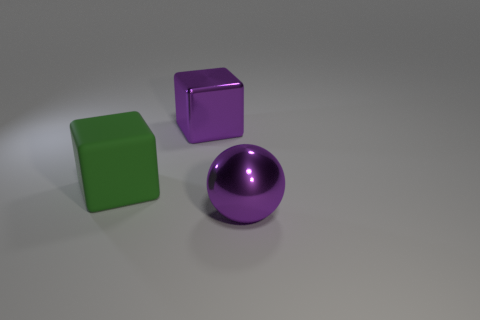Add 3 large blocks. How many objects exist? 6 Subtract all spheres. How many objects are left? 2 Subtract 0 cyan cylinders. How many objects are left? 3 Subtract all cubes. Subtract all tiny yellow blocks. How many objects are left? 1 Add 1 big things. How many big things are left? 4 Add 1 shiny blocks. How many shiny blocks exist? 2 